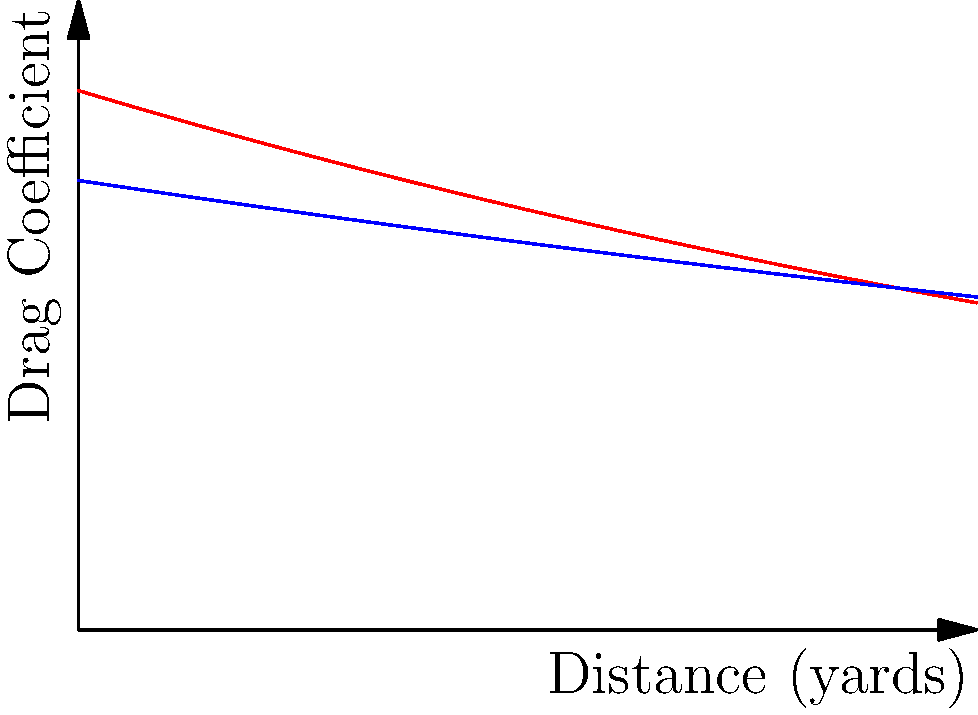Based on the drag coefficient curves shown for two different bullets, which bullet would likely maintain its velocity better over long distances, and why? To determine which bullet would maintain its velocity better over long distances, we need to analyze the drag coefficient curves:

1. The drag coefficient is a measure of air resistance on the bullet. Lower drag coefficients result in better velocity retention.

2. Observe that both curves start at different points:
   - Bullet A (red) starts at a higher drag coefficient (about 0.6)
   - Bullet B (blue) starts at a lower drag coefficient (about 0.5)

3. As distance increases, both curves decrease, indicating reduced drag:
   - Bullet A's curve decreases more rapidly
   - Bullet B's curve decreases more gradually

4. At longer distances (beyond 500 yards):
   - Bullet A's drag coefficient becomes lower than Bullet B's
   - This crossover indicates that Bullet A experiences less drag at extreme ranges

5. The area under each curve represents the total drag experienced:
   - Bullet A has a smaller area under its curve beyond the crossover point
   - This suggests less cumulative drag for Bullet A at longer ranges

6. For long-range shooting, the behavior at extended distances is crucial:
   - Bullet A's lower drag coefficient at longer ranges is advantageous

Therefore, despite starting with a higher drag coefficient, Bullet A would likely maintain its velocity better over long distances due to its superior aerodynamic performance at extended ranges.
Answer: Bullet A, due to lower drag at extended ranges. 